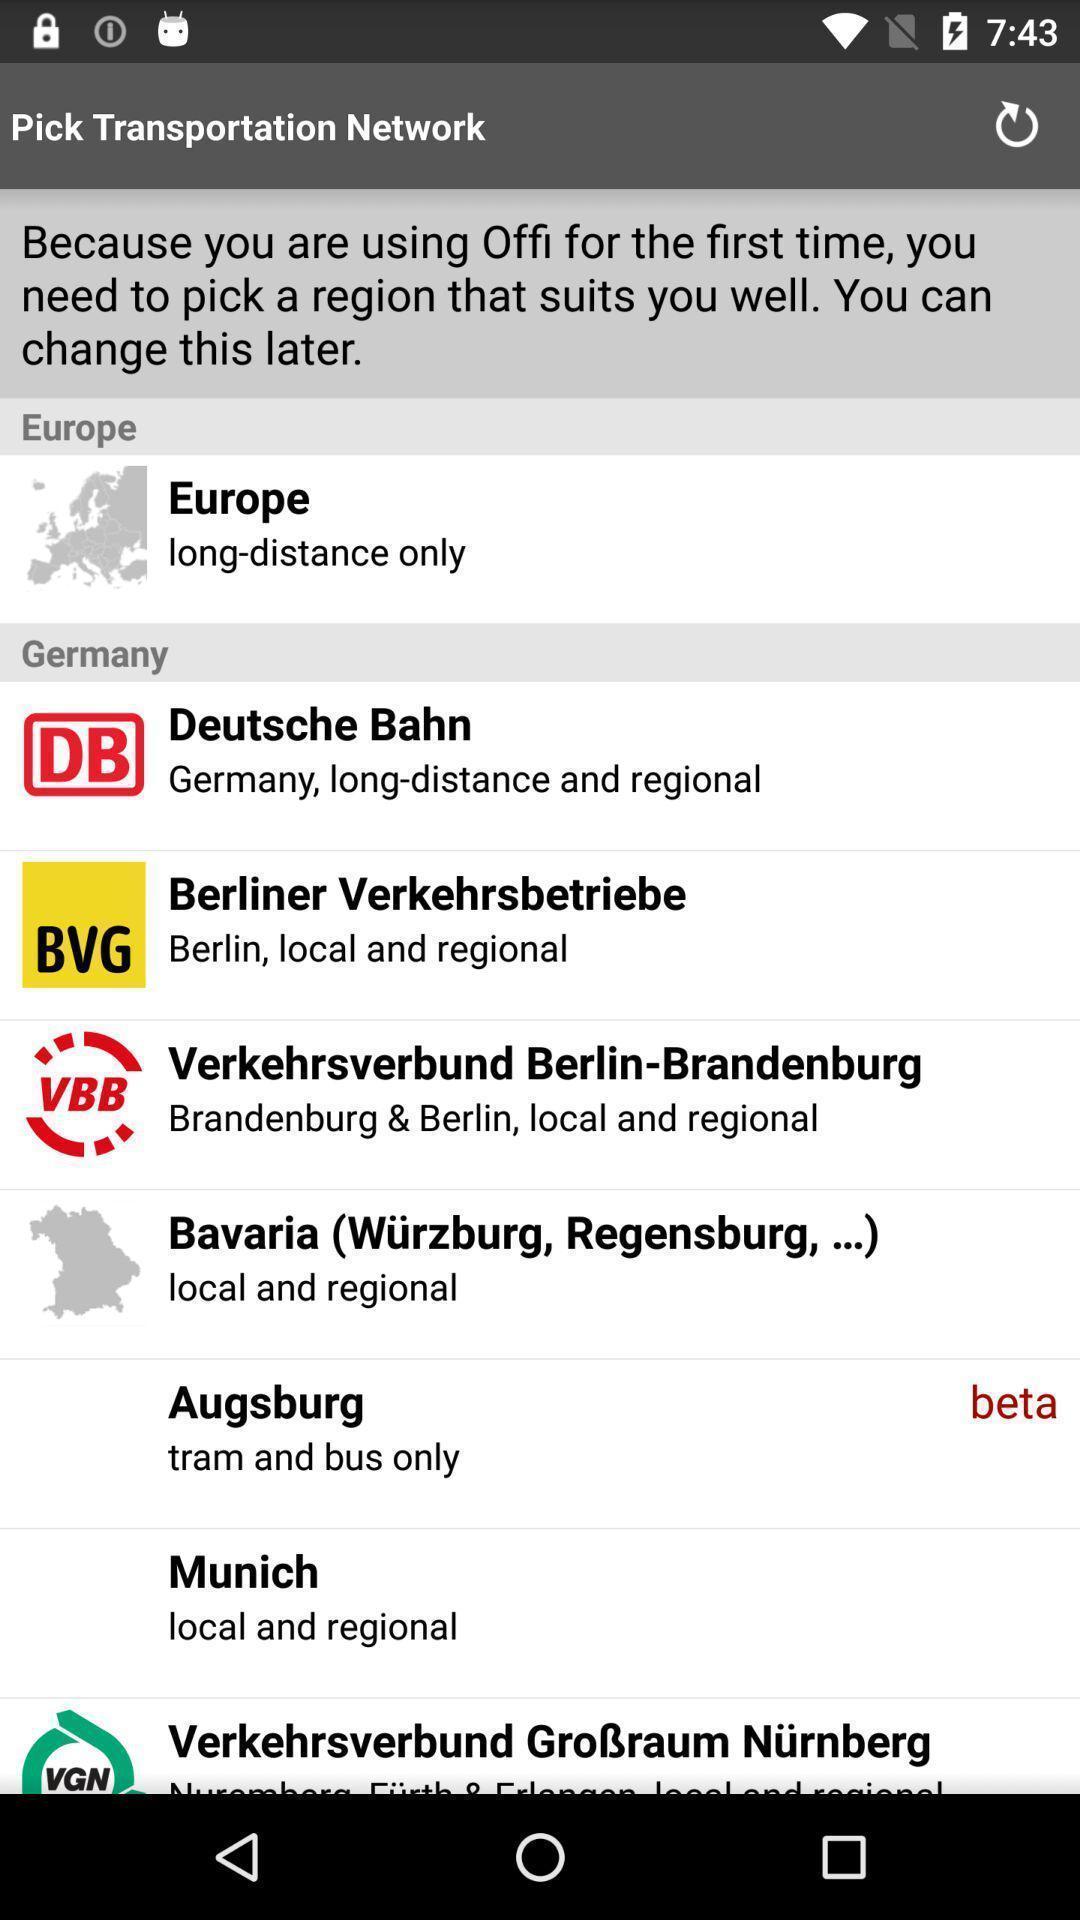Tell me about the visual elements in this screen capture. Transport app page shows list of countries in europe. 